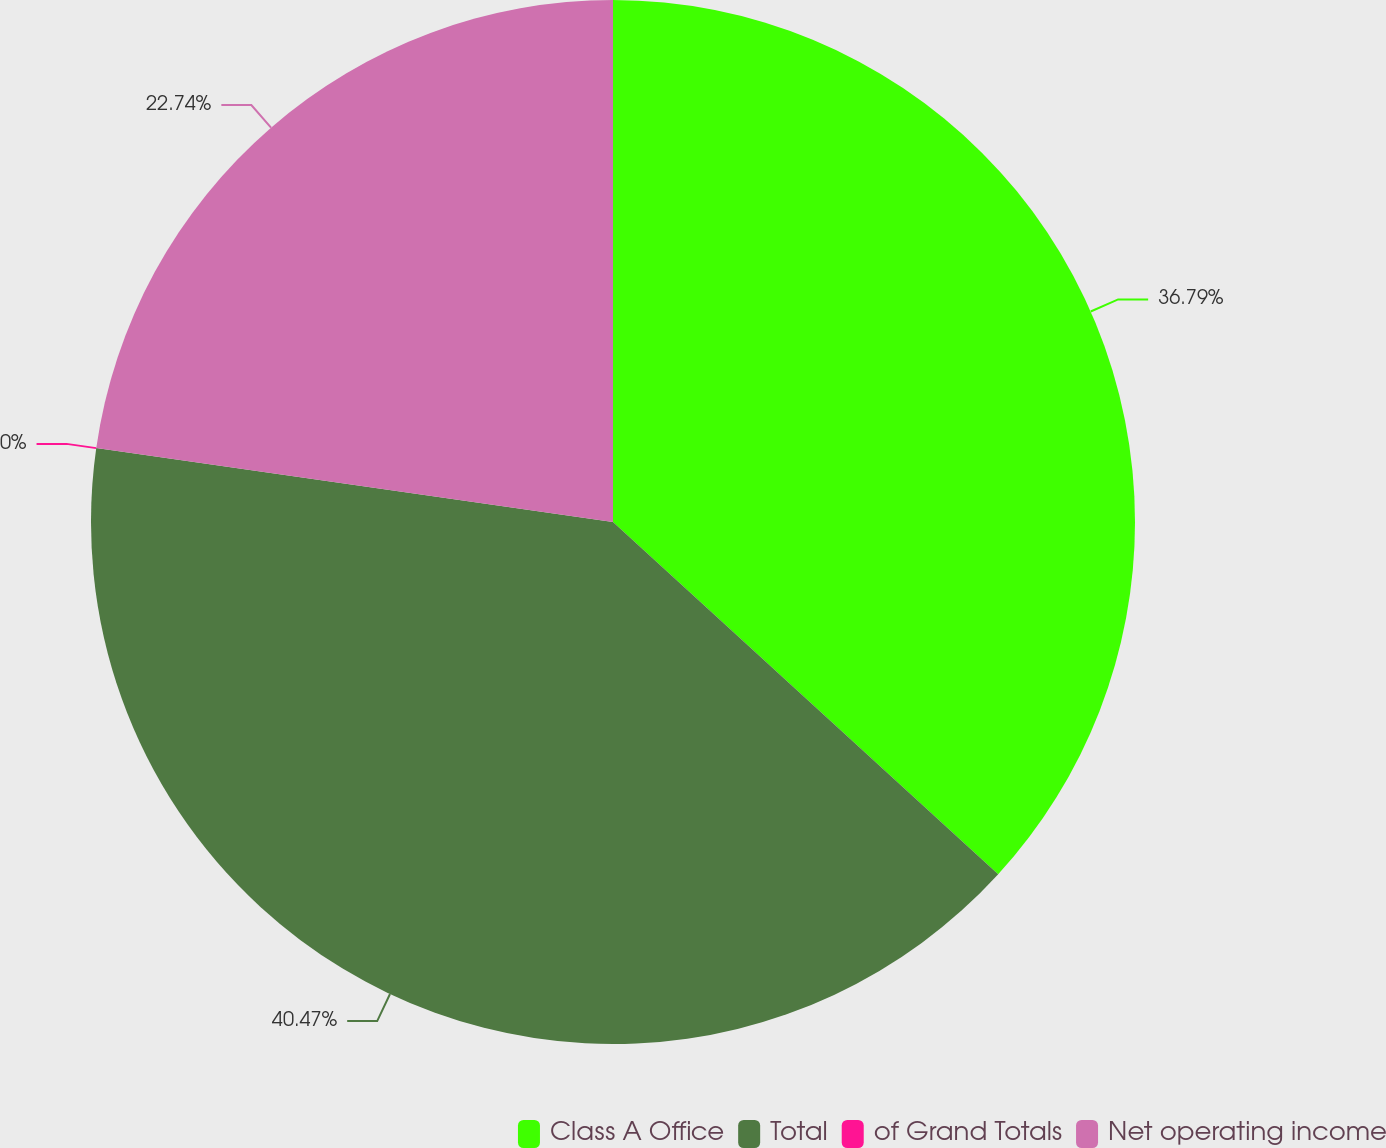Convert chart. <chart><loc_0><loc_0><loc_500><loc_500><pie_chart><fcel>Class A Office<fcel>Total<fcel>of Grand Totals<fcel>Net operating income<nl><fcel>36.79%<fcel>40.47%<fcel>0.0%<fcel>22.74%<nl></chart> 